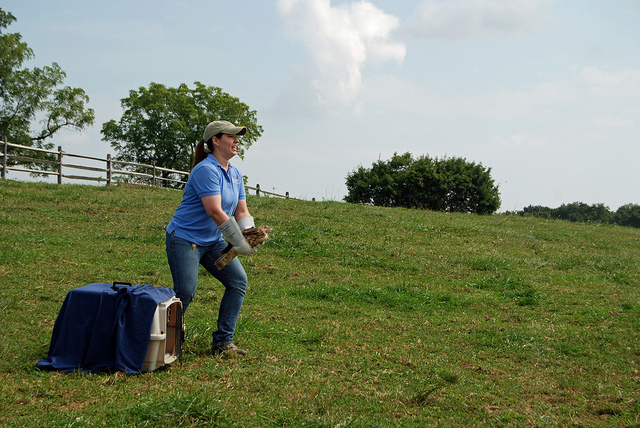<image>What trick is being shown in this scene? I am not sure what trick is being shown in the scene. It may involve something with birds. What pattern is on the man's shirt? I don't know the pattern on the man's shirt. It can be plain blue or solid blue. What pattern is on the man's shirt? I am not sure what pattern is on the man's shirt. It is not clear from the answers given. What trick is being shown in this scene? I am not sure what trick is being shown in this scene. It can be 'bird flight', 'owling', 'throw', or 'catching'. 